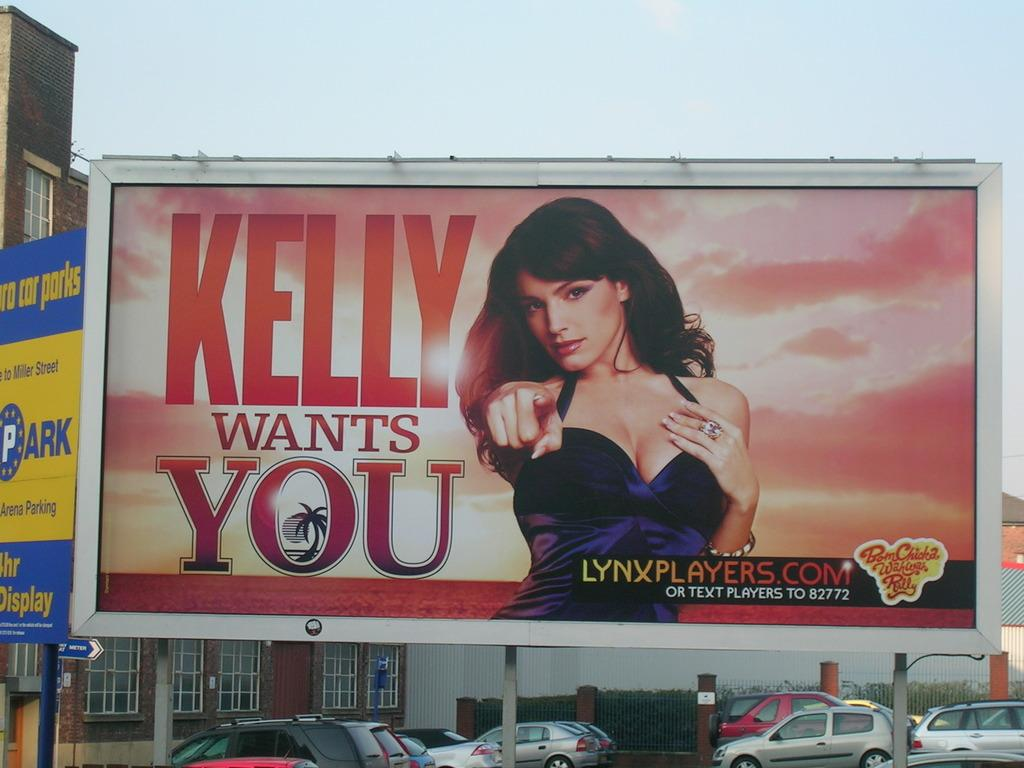<image>
Share a concise interpretation of the image provided. A billboard that reads Kelly Wants You sits outside of a building above cars 